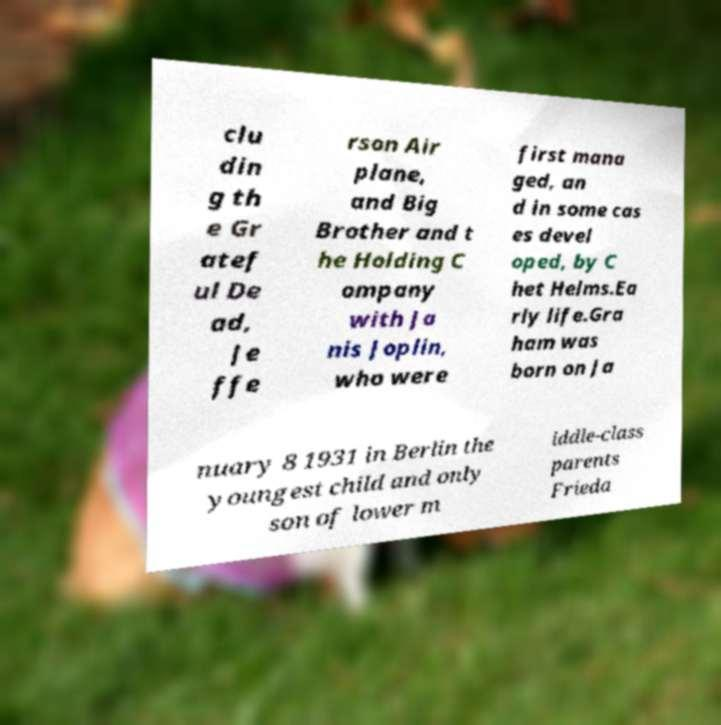Please identify and transcribe the text found in this image. clu din g th e Gr atef ul De ad, Je ffe rson Air plane, and Big Brother and t he Holding C ompany with Ja nis Joplin, who were first mana ged, an d in some cas es devel oped, by C het Helms.Ea rly life.Gra ham was born on Ja nuary 8 1931 in Berlin the youngest child and only son of lower m iddle-class parents Frieda 